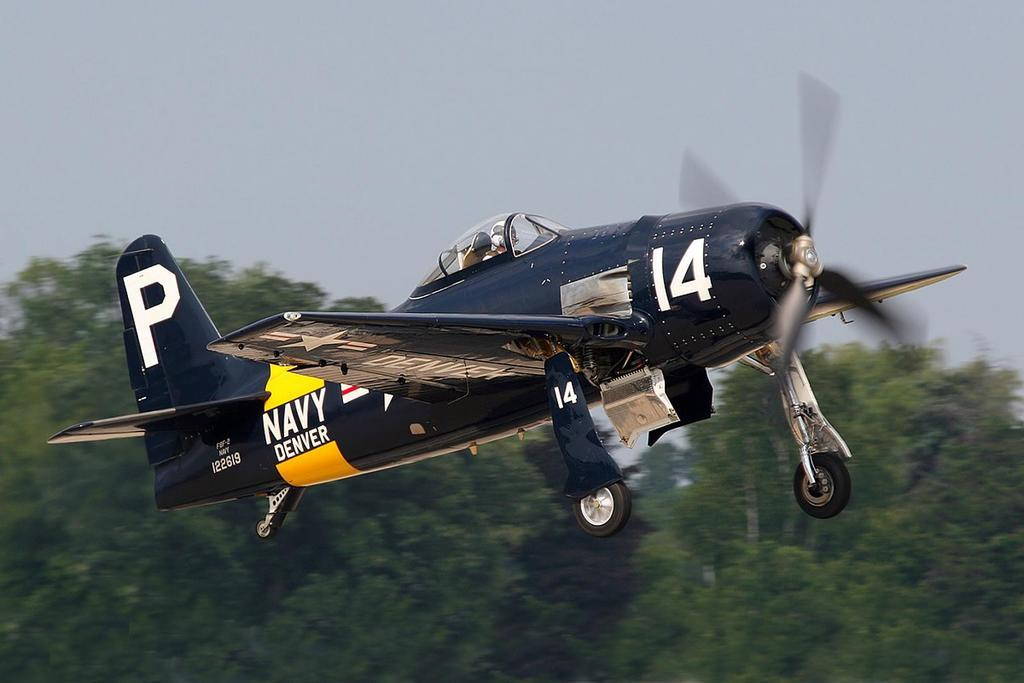What is the main subject of the image? The main subject of the image is an airplane. What are the main features of the airplane? The airplane has wheels, wings, and a propeller. What else can be seen in the image besides the airplane? There are trees in the image. What is visible at the top of the image? The sky is visible at the top of the image. What type of society can be seen interacting with the airplane in the image? There is no society present in the image; it only features an airplane and trees. Can you tell me how many elbows are visible on the airplane in the image? Airplanes do not have elbows, as they are inanimate objects. 